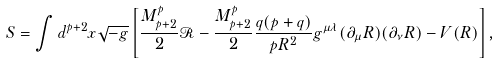Convert formula to latex. <formula><loc_0><loc_0><loc_500><loc_500>S = \int d ^ { p + 2 } x \sqrt { - g } \left [ \frac { M _ { p + 2 } ^ { p } } { 2 } \mathcal { R } - \frac { M _ { p + 2 } ^ { p } } { 2 } \frac { q ( p + q ) } { p R ^ { 2 } } g ^ { \mu \lambda } ( \partial _ { \mu } R ) ( \partial _ { \nu } R ) - V ( R ) \right ] ,</formula> 